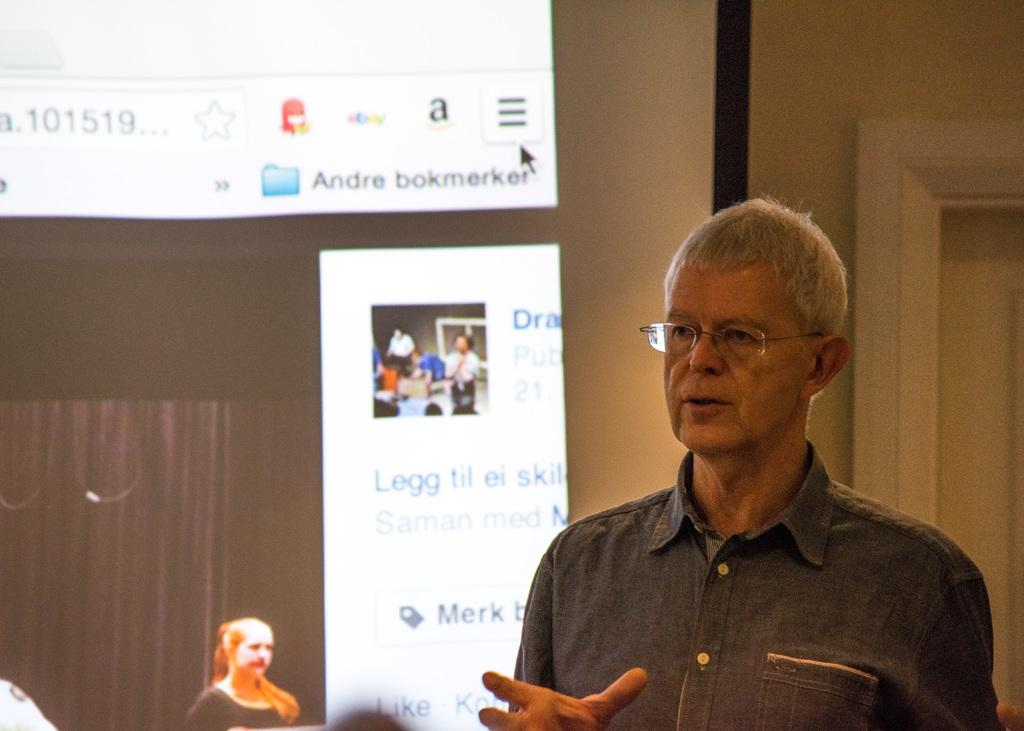What is the main subject of the image? There is a person standing in the image. Can you describe the person's appearance? The person is wearing glasses. What can be seen in the background of the image? There is a screen, a door, and a wall in the background of the image. What type of sign is the person holding in the image? There is no sign present in the image; the person is not holding anything. How many nails can be seen on the wall in the image? There is no mention of nails in the image; only a wall is described in the background. 